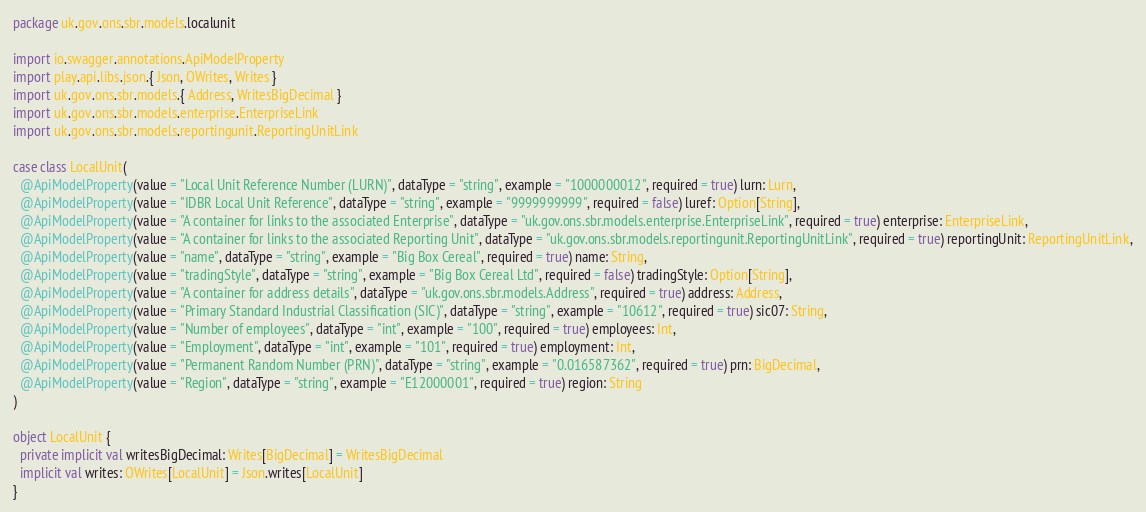Convert code to text. <code><loc_0><loc_0><loc_500><loc_500><_Scala_>package uk.gov.ons.sbr.models.localunit

import io.swagger.annotations.ApiModelProperty
import play.api.libs.json.{ Json, OWrites, Writes }
import uk.gov.ons.sbr.models.{ Address, WritesBigDecimal }
import uk.gov.ons.sbr.models.enterprise.EnterpriseLink
import uk.gov.ons.sbr.models.reportingunit.ReportingUnitLink

case class LocalUnit(
  @ApiModelProperty(value = "Local Unit Reference Number (LURN)", dataType = "string", example = "1000000012", required = true) lurn: Lurn,
  @ApiModelProperty(value = "IDBR Local Unit Reference", dataType = "string", example = "9999999999", required = false) luref: Option[String],
  @ApiModelProperty(value = "A container for links to the associated Enterprise", dataType = "uk.gov.ons.sbr.models.enterprise.EnterpriseLink", required = true) enterprise: EnterpriseLink,
  @ApiModelProperty(value = "A container for links to the associated Reporting Unit", dataType = "uk.gov.ons.sbr.models.reportingunit.ReportingUnitLink", required = true) reportingUnit: ReportingUnitLink,
  @ApiModelProperty(value = "name", dataType = "string", example = "Big Box Cereal", required = true) name: String,
  @ApiModelProperty(value = "tradingStyle", dataType = "string", example = "Big Box Cereal Ltd", required = false) tradingStyle: Option[String],
  @ApiModelProperty(value = "A container for address details", dataType = "uk.gov.ons.sbr.models.Address", required = true) address: Address,
  @ApiModelProperty(value = "Primary Standard Industrial Classification (SIC)", dataType = "string", example = "10612", required = true) sic07: String,
  @ApiModelProperty(value = "Number of employees", dataType = "int", example = "100", required = true) employees: Int,
  @ApiModelProperty(value = "Employment", dataType = "int", example = "101", required = true) employment: Int,
  @ApiModelProperty(value = "Permanent Random Number (PRN)", dataType = "string", example = "0.016587362", required = true) prn: BigDecimal,
  @ApiModelProperty(value = "Region", dataType = "string", example = "E12000001", required = true) region: String
)

object LocalUnit {
  private implicit val writesBigDecimal: Writes[BigDecimal] = WritesBigDecimal
  implicit val writes: OWrites[LocalUnit] = Json.writes[LocalUnit]
}</code> 